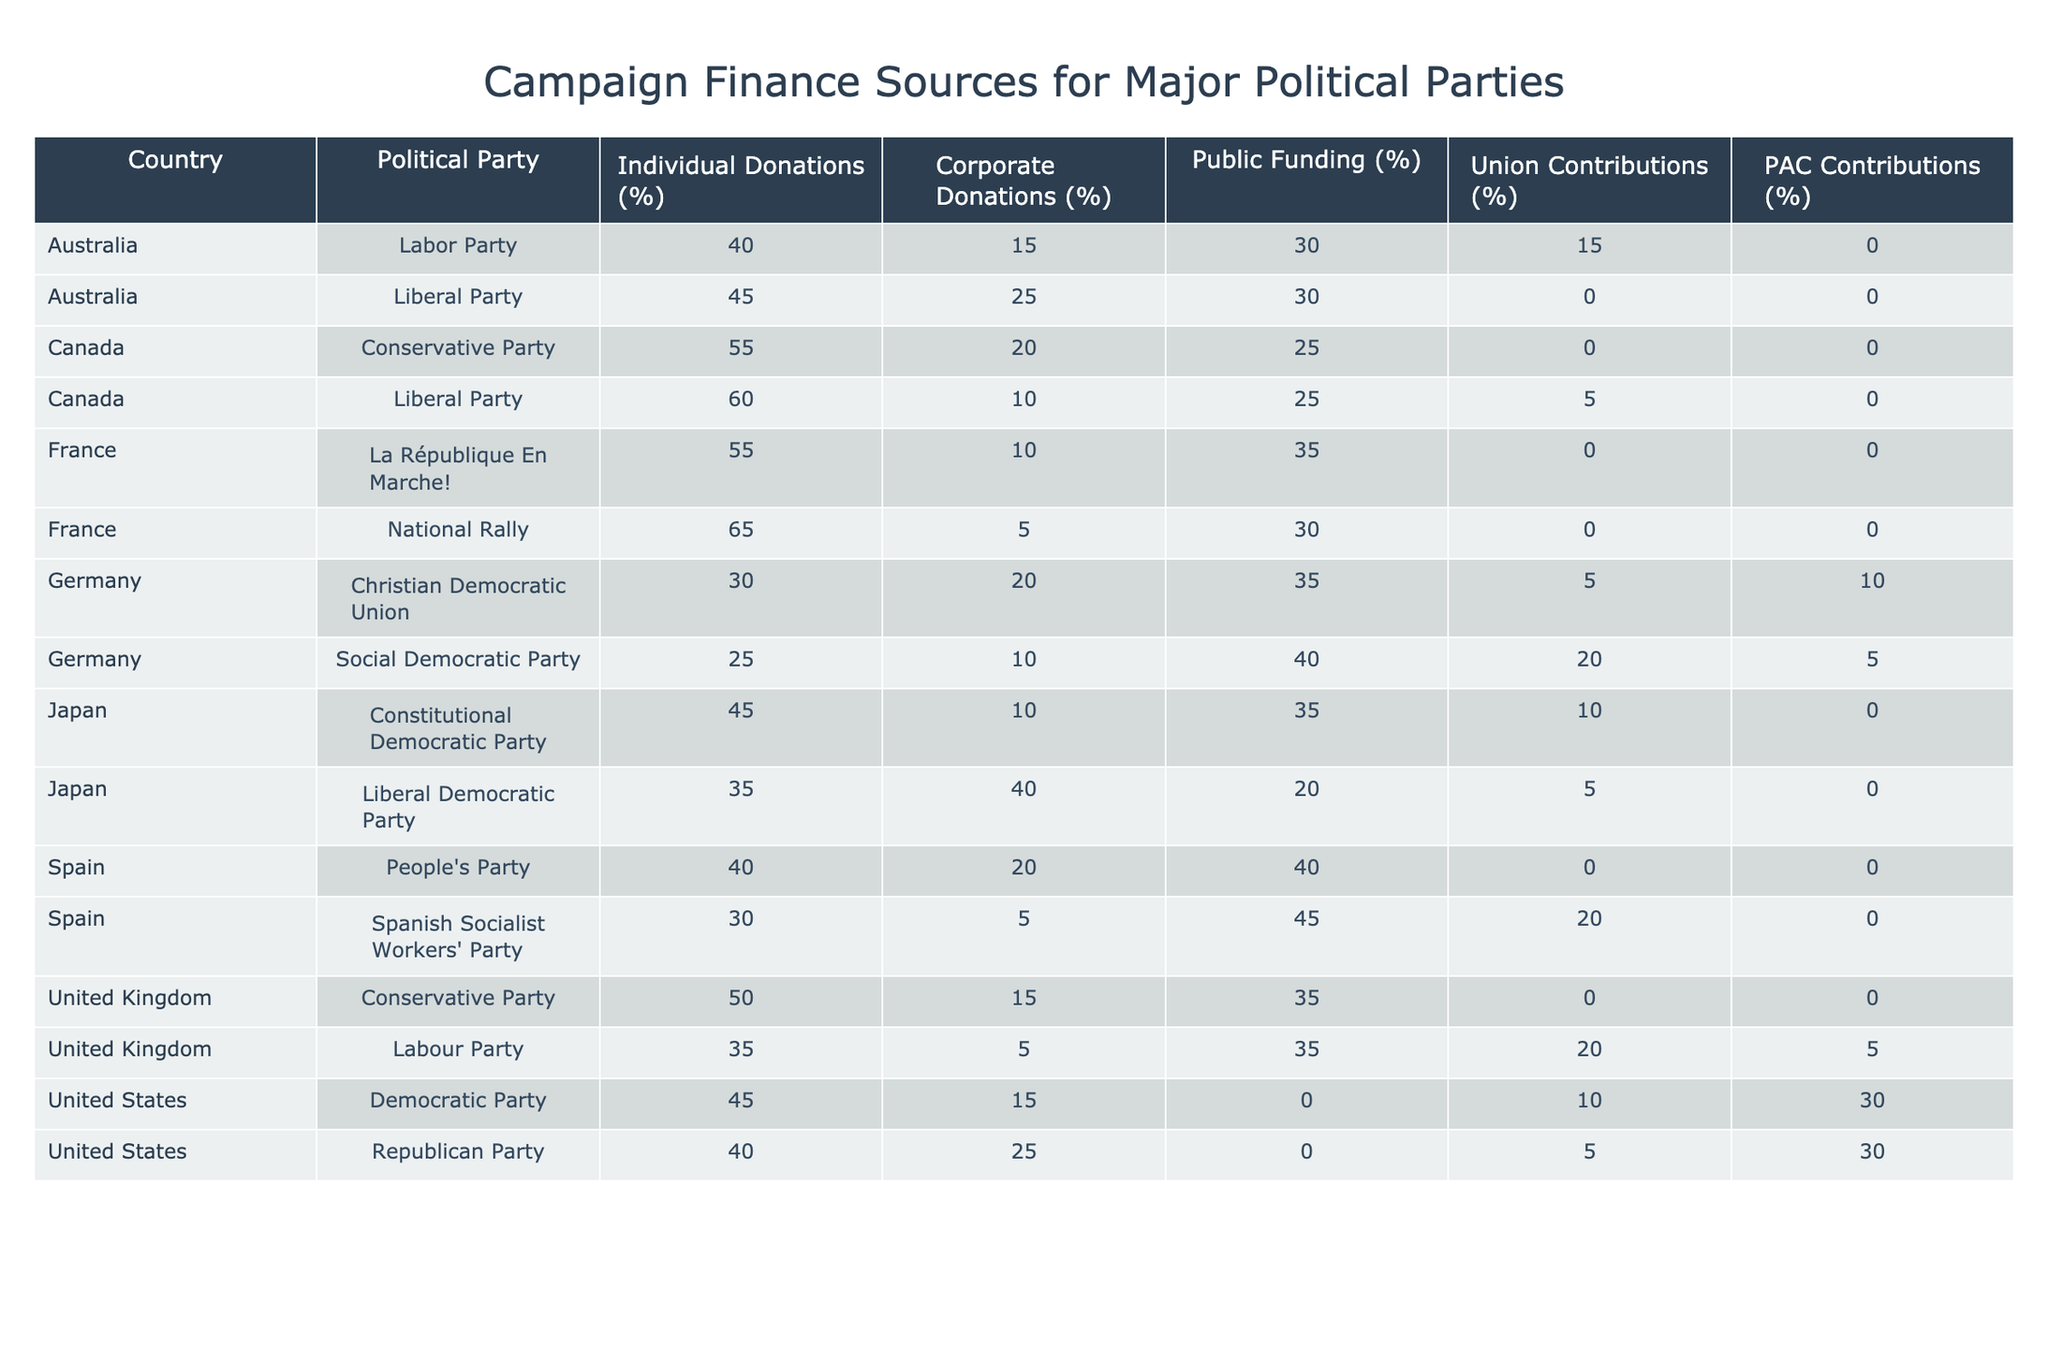What percentage of donations does the National Rally receive from individual sources? From the table, the National Rally has 65% of its donations coming from individual sources.
Answer: 65% Which political party in Germany receives the highest corporate donations? The political party in Germany that receives the highest corporate donations is the Christian Democratic Union with 20%.
Answer: Christian Democratic Union What is the total percentage of public funding for political parties in the United Kingdom? The Labour Party and the Conservative Party in the United Kingdom both receive public funding. The Labour Party has 35%, and the Conservative Party has 35%, thus the total is 35% + 35% = 70%.
Answer: 70% Do both major political parties in Canada rely on the same source for contributions? No, the Liberal Party relies heavily on individual donations (60%), while the Conservative Party also relies on individual donations (55%) but has a broader corporate contribution percentage (20%).
Answer: No Which party has the lowest percentage of union contributions and what is that percentage? The Conservative Party in the United Kingdom has the lowest percentage of union contributions at 0%.
Answer: 0% What is the average percentage of corporate donations for all political parties in Spain? The corporate donations for the Spanish Socialist Workers' Party is 5% and for the People's Party is 20%. The average is calculated as (5% + 20%)/2 = 12.5%.
Answer: 12.5% Which party has the highest reliance on PAC contributions and what is that percentage? Both the Democratic Party and the Republican Party in the United States each have 30% reliance on PAC contributions, the highest among the listed parties.
Answer: 30% Is public funding a more significant source for the Labour Party than for the Christian Democratic Union? Yes, the Labour Party receives 35% from public funding while the Christian Democratic Union receives only 35%.
Answer: Yes In terms of individual contributions, which party has the largest gap compared to its corporate contributions? The National Rally in France has the largest gap with 65% from individuals and 5% from corporate contributions, which gives a gap of 60%.
Answer: National Rally 